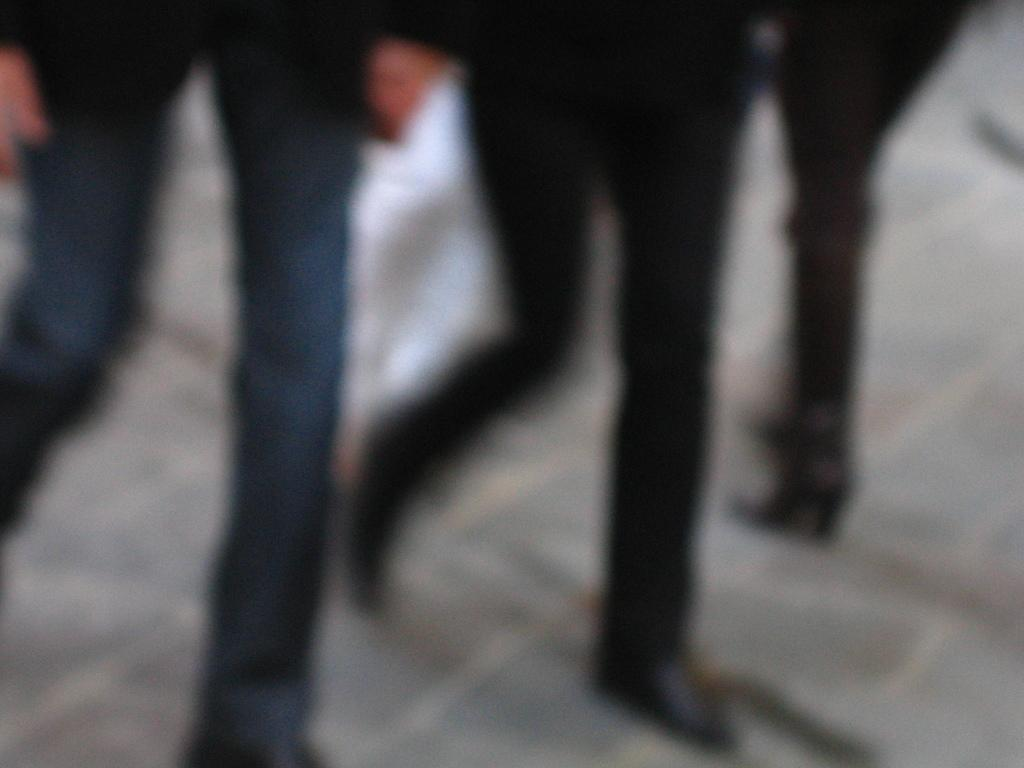How many people are present in the image? There are three people in the image. What are the people in the image doing? The people are walking on the floor. What type of afterthought can be seen in the image? There is no afterthought present in the image. Can you describe the nest in the image? There is no nest present in the image. 